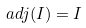Convert formula to latex. <formula><loc_0><loc_0><loc_500><loc_500>a d j ( I ) = I</formula> 